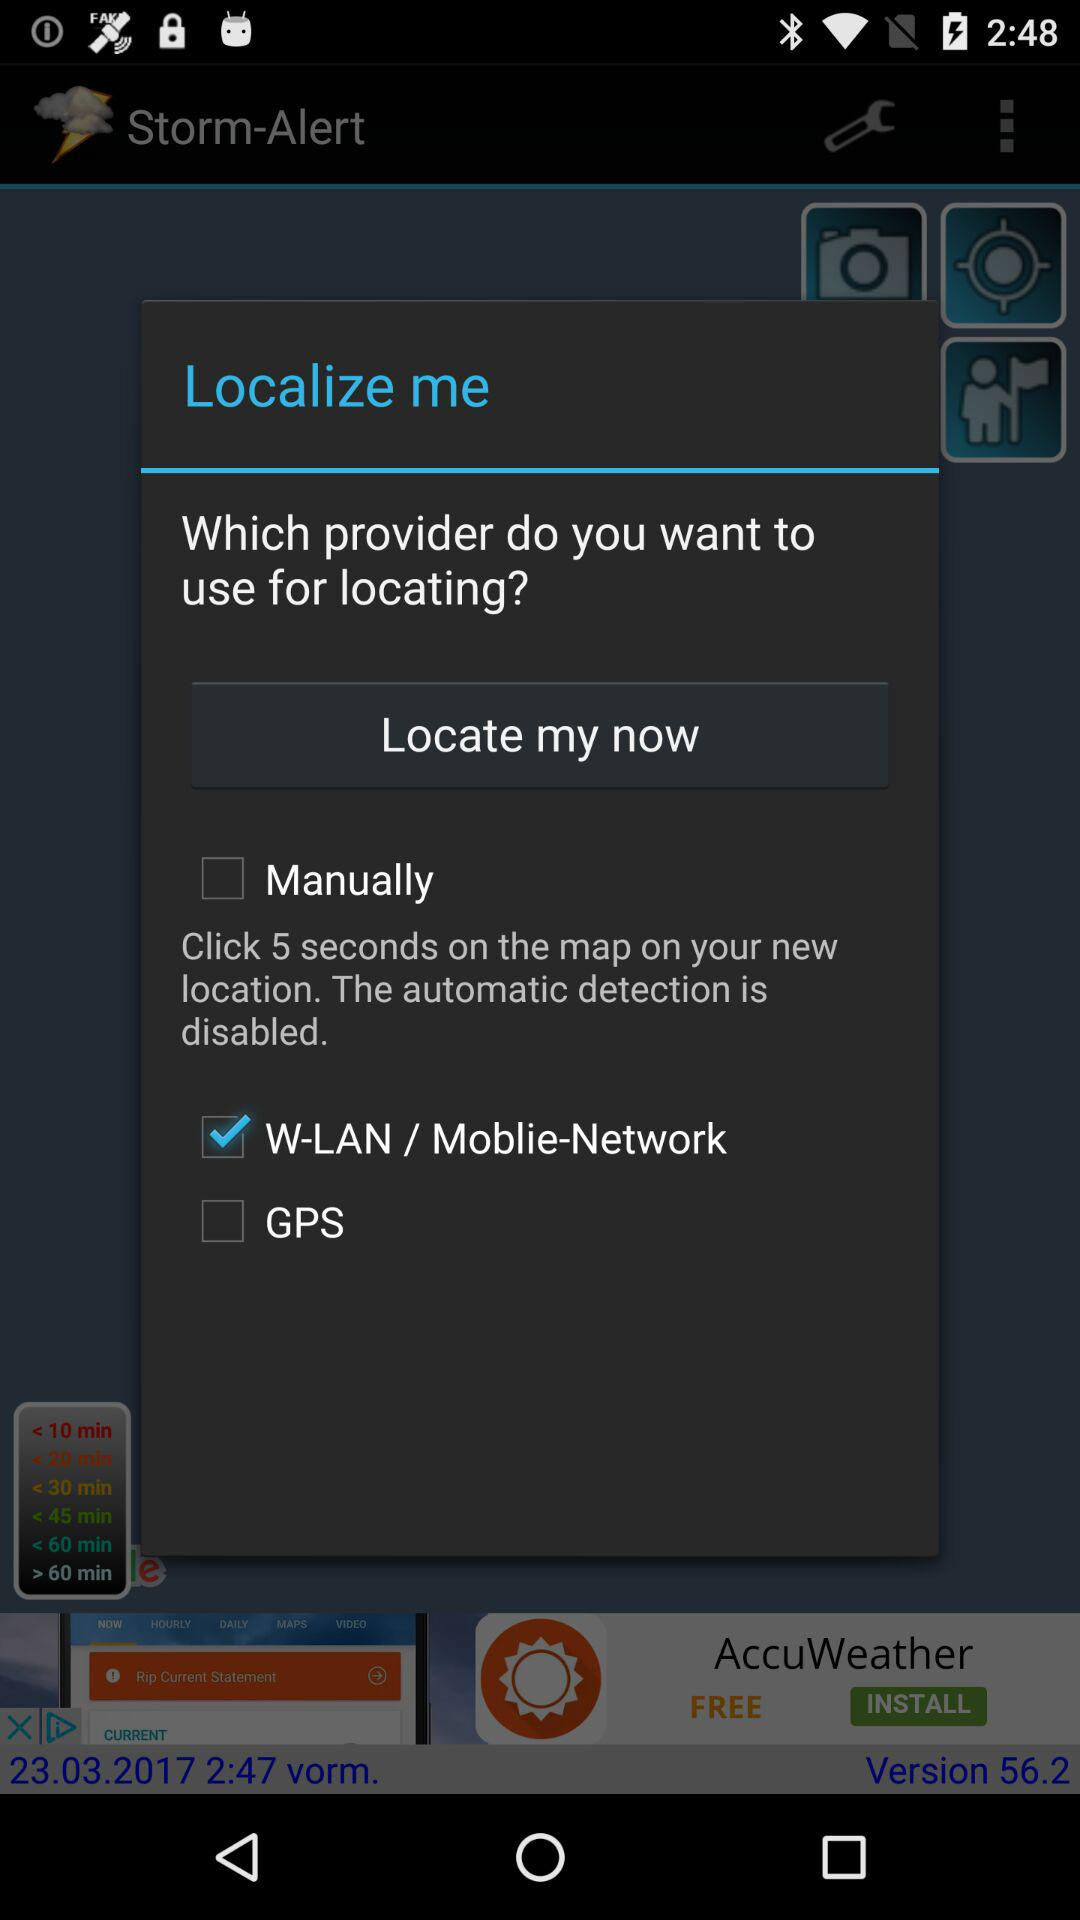For how many seconds do I have to click on the map at my new location? You have to click for 5 seconds on the map at your new location. 